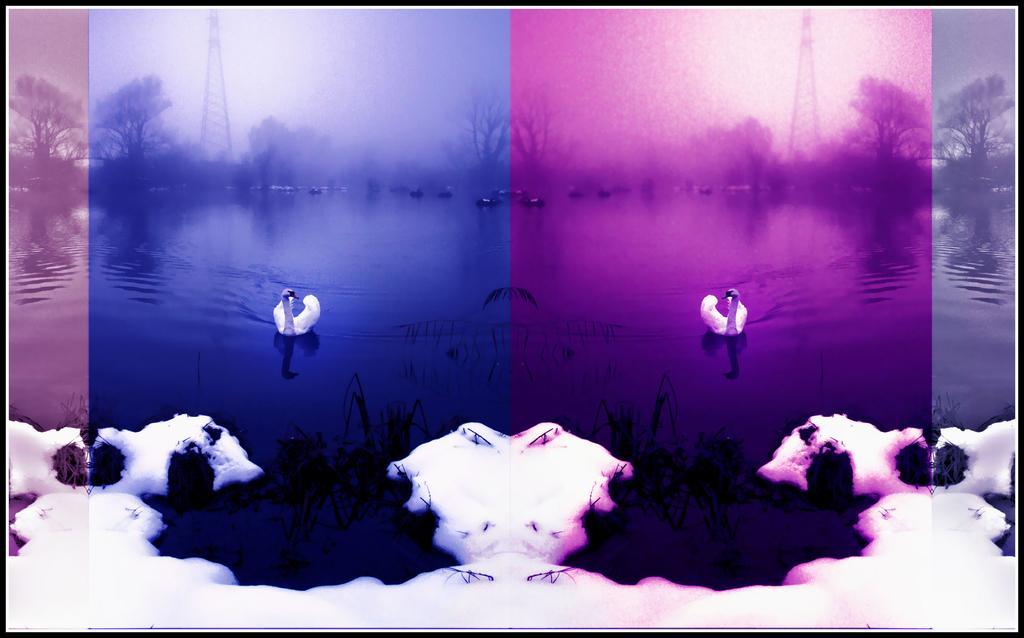How would you summarize this image in a sentence or two? In this I can see pink and violet color image with snow. And there are ducks in a water. And at the background there is a tower and a tree. 